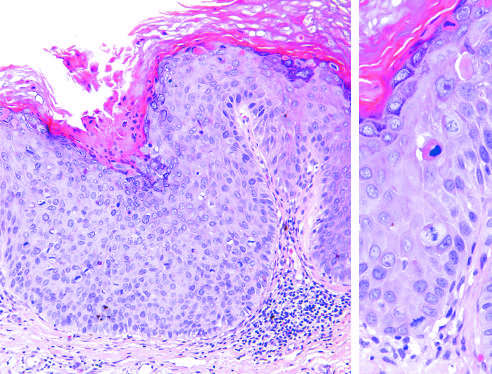what shows several mitotic figures, some above the basal layer, and nuclear pleomorphism?
Answer the question using a single word or phrase. Higher magnification 